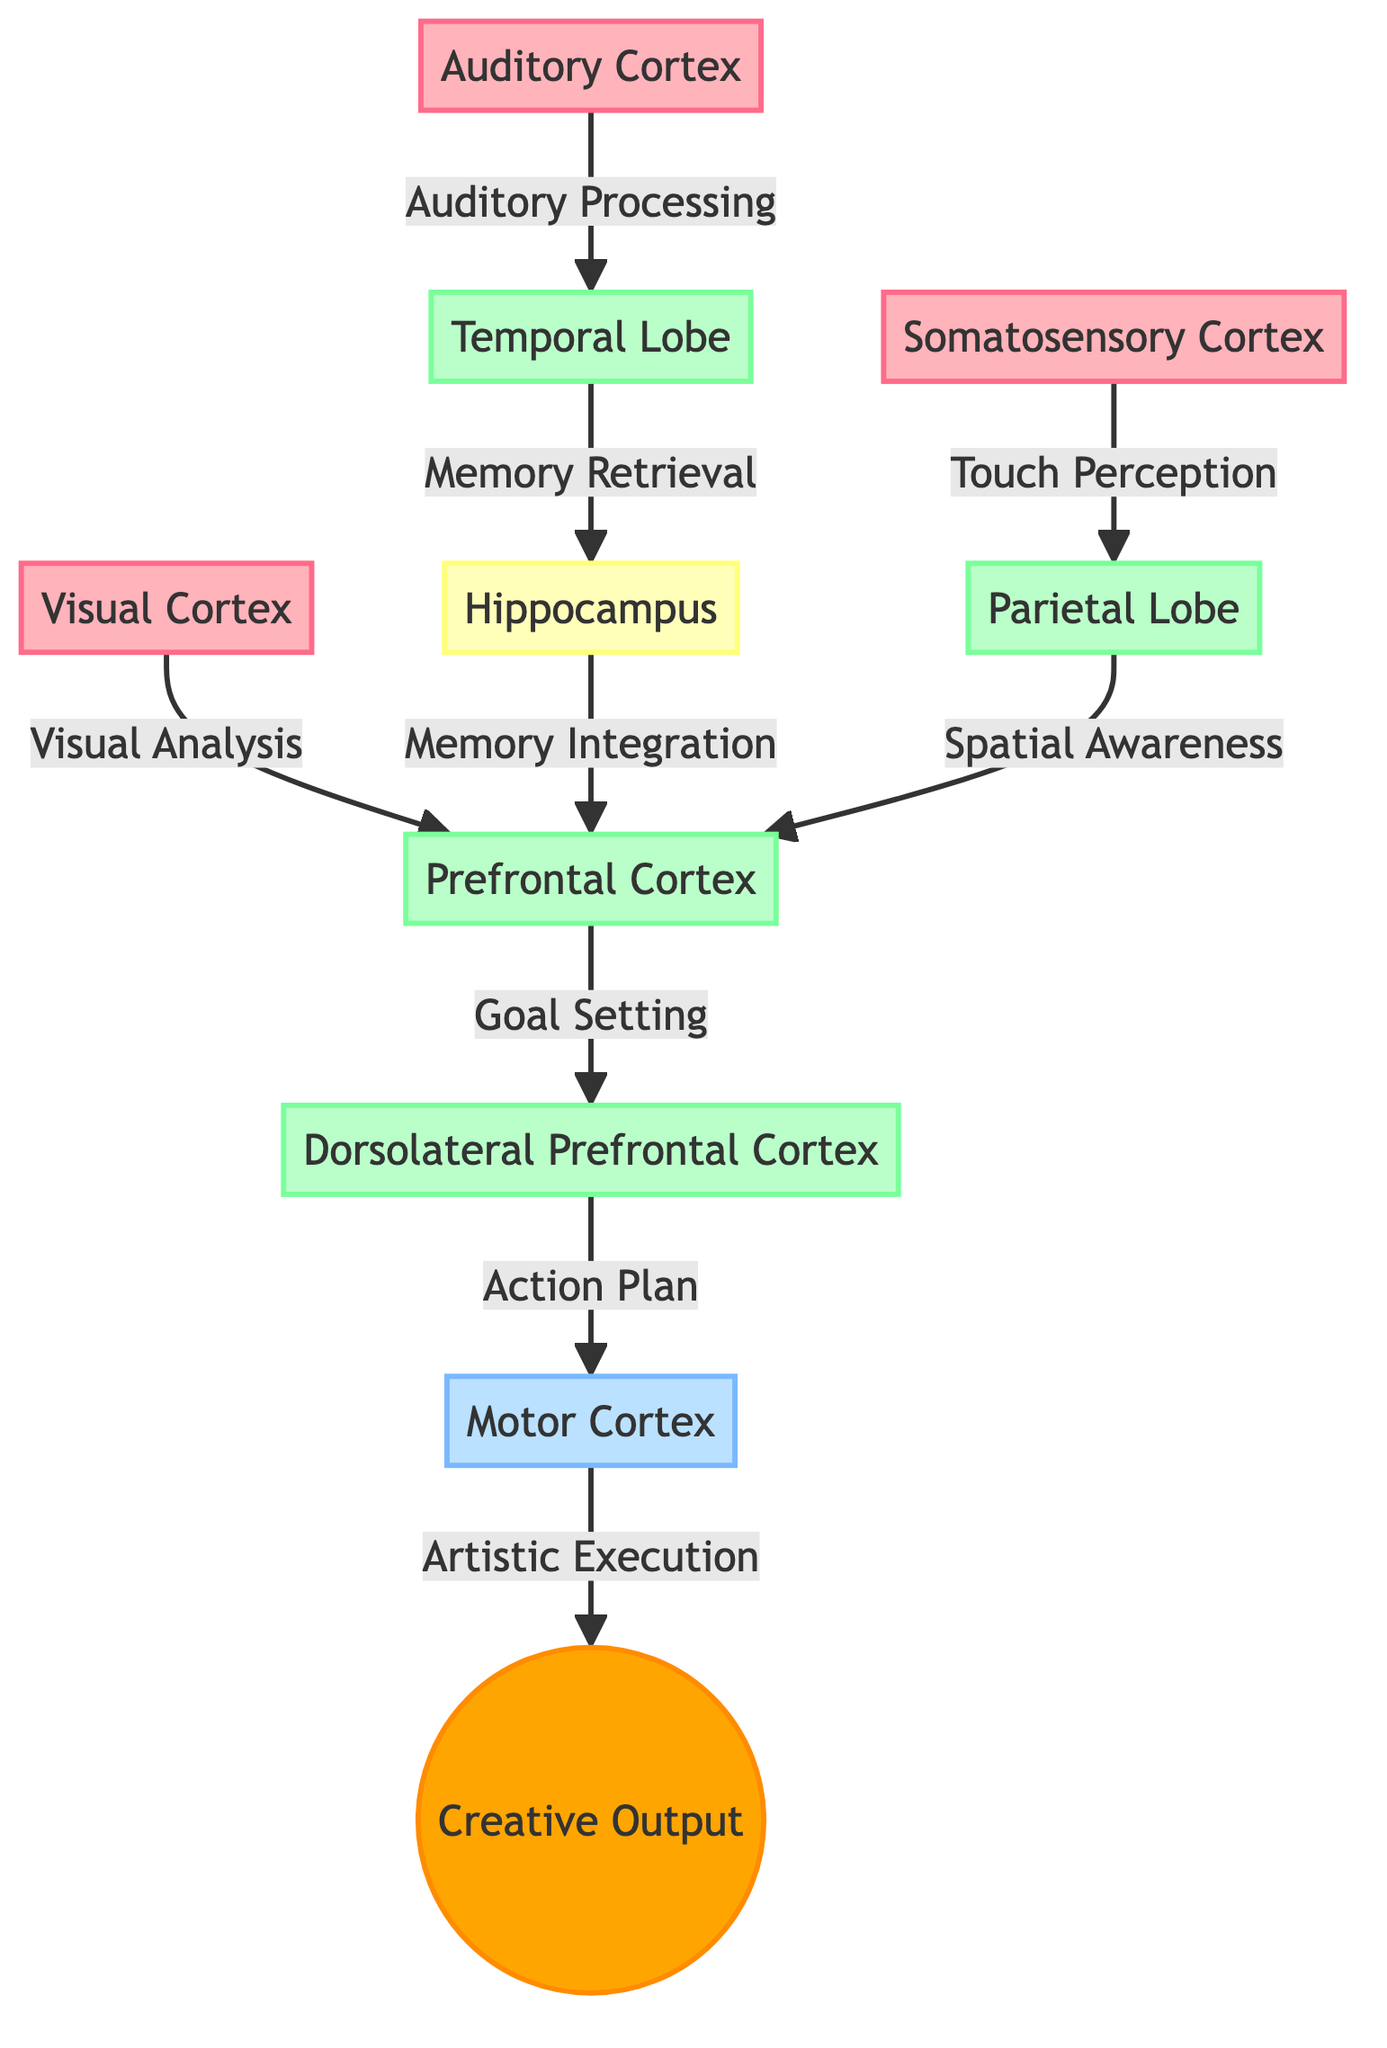What types of nodes are present in the diagram? The diagram contains nodes representing sensory input, cognitive processes, memory, and creative output. This is identified based on the node labels and their classifications in the diagram.
Answer: sensory_input, cognitive_process, memory, creative_output How many nodes are in this diagram? By counting the listed nodes in the data, there are a total of 9 distinct nodes. This includes Visual Cortex, Auditory Cortex, Somatosensory Cortex, Prefrontal Cortex, Temporal Lobe, Parietal Lobe, Motor Cortex, Dorsolateral Prefrontal Cortex, and Hippocampus.
Answer: 9 What does the edge from the Visual Cortex to the Prefrontal Cortex represent? The edge from Visual Cortex to Prefrontal Cortex is labeled "Visual Analysis," indicating the flow of information and its role in cognitive processing during artmaking.
Answer: Visual Analysis Which node is responsible for memory retrieval? The node labeled "Temporal Lobe" is connected to the Hippocampus by the edge labeled "Memory Retrieval," indicating its role in retrieving memories related to artistic creativity.
Answer: Temporal Lobe Which two nodes interact to form an action plan? The Dorsolateral Prefrontal Cortex and Motor Cortex interact to form an action plan, connected by the edge labeled "Action Plan." This indicates the process of planning movements necessary for artistic execution.
Answer: Dorsolateral Prefrontal Cortex and Motor Cortex How does auditory processing relate to memory? The edge from Auditory Cortex to Temporal Lobe indicates that auditory processing occurs first, which in turn connects to the Hippocampus for memory retrieval—suggesting that auditory inputs are integrated with memory mechanisms.
Answer: Auditory Processing to Memory Retrieval What is the flow from the Hippocampus to the Prefrontal Cortex? The flow goes from the Hippocampus (via "Memory Integration") to the Prefrontal Cortex. This shows that integrated memories inform cognitive decision-making in the creative process.
Answer: Memory Integration How many connections are there from sensory input nodes to cognitive process nodes? There are three sensory input nodes—Visual Cortex, Auditory Cortex, and Somatosensory Cortex—each connected to a cognitive process node, resulting in a total of 3 connections from sensory inputs to cognitive processes.
Answer: 3 Which cognitive process is linked to spatial awareness? The Parietal Lobe is the cognitive process linked to spatial awareness, as indicated by the edge connecting it to the Prefrontal Cortex for processing spatial information related to creativity.
Answer: Parietal Lobe 